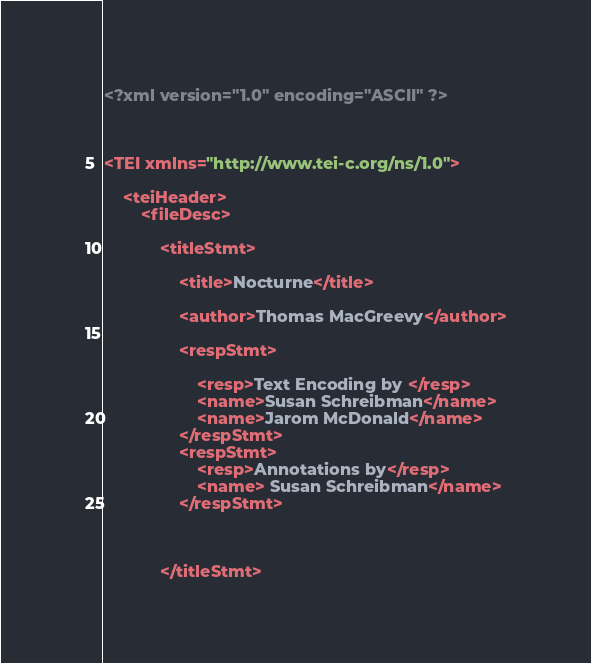Convert code to text. <code><loc_0><loc_0><loc_500><loc_500><_XML_><?xml version="1.0" encoding="ASCII" ?>



<TEI xmlns="http://www.tei-c.org/ns/1.0">

    <teiHeader>
        <fileDesc>

            <titleStmt>

                <title>Nocturne</title>

                <author>Thomas MacGreevy</author>

                <respStmt>

                    <resp>Text Encoding by </resp>
                    <name>Susan Schreibman</name>
                    <name>Jarom McDonald</name>
                </respStmt>
                <respStmt>
                    <resp>Annotations by</resp>
                    <name> Susan Schreibman</name>
                </respStmt>



            </titleStmt>
</code> 